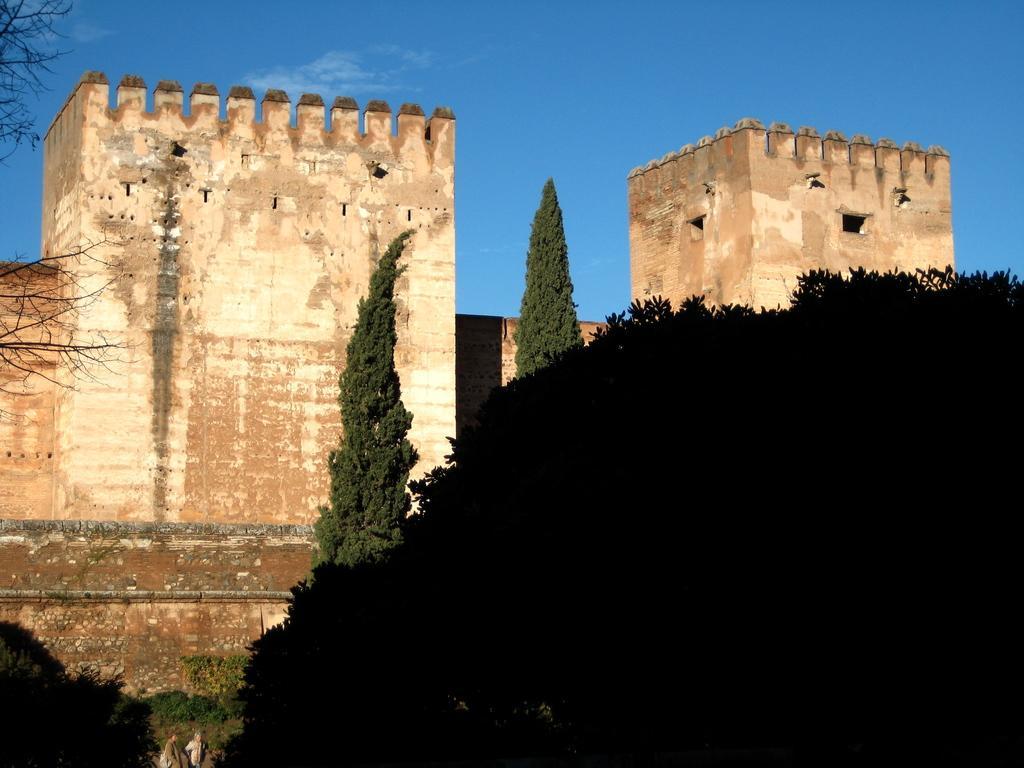Could you give a brief overview of what you see in this image? This is an outside view. At the bottom there are many trees. In the middle of the image there are few buildings. At the top of the image I can see the sky in blue color. 